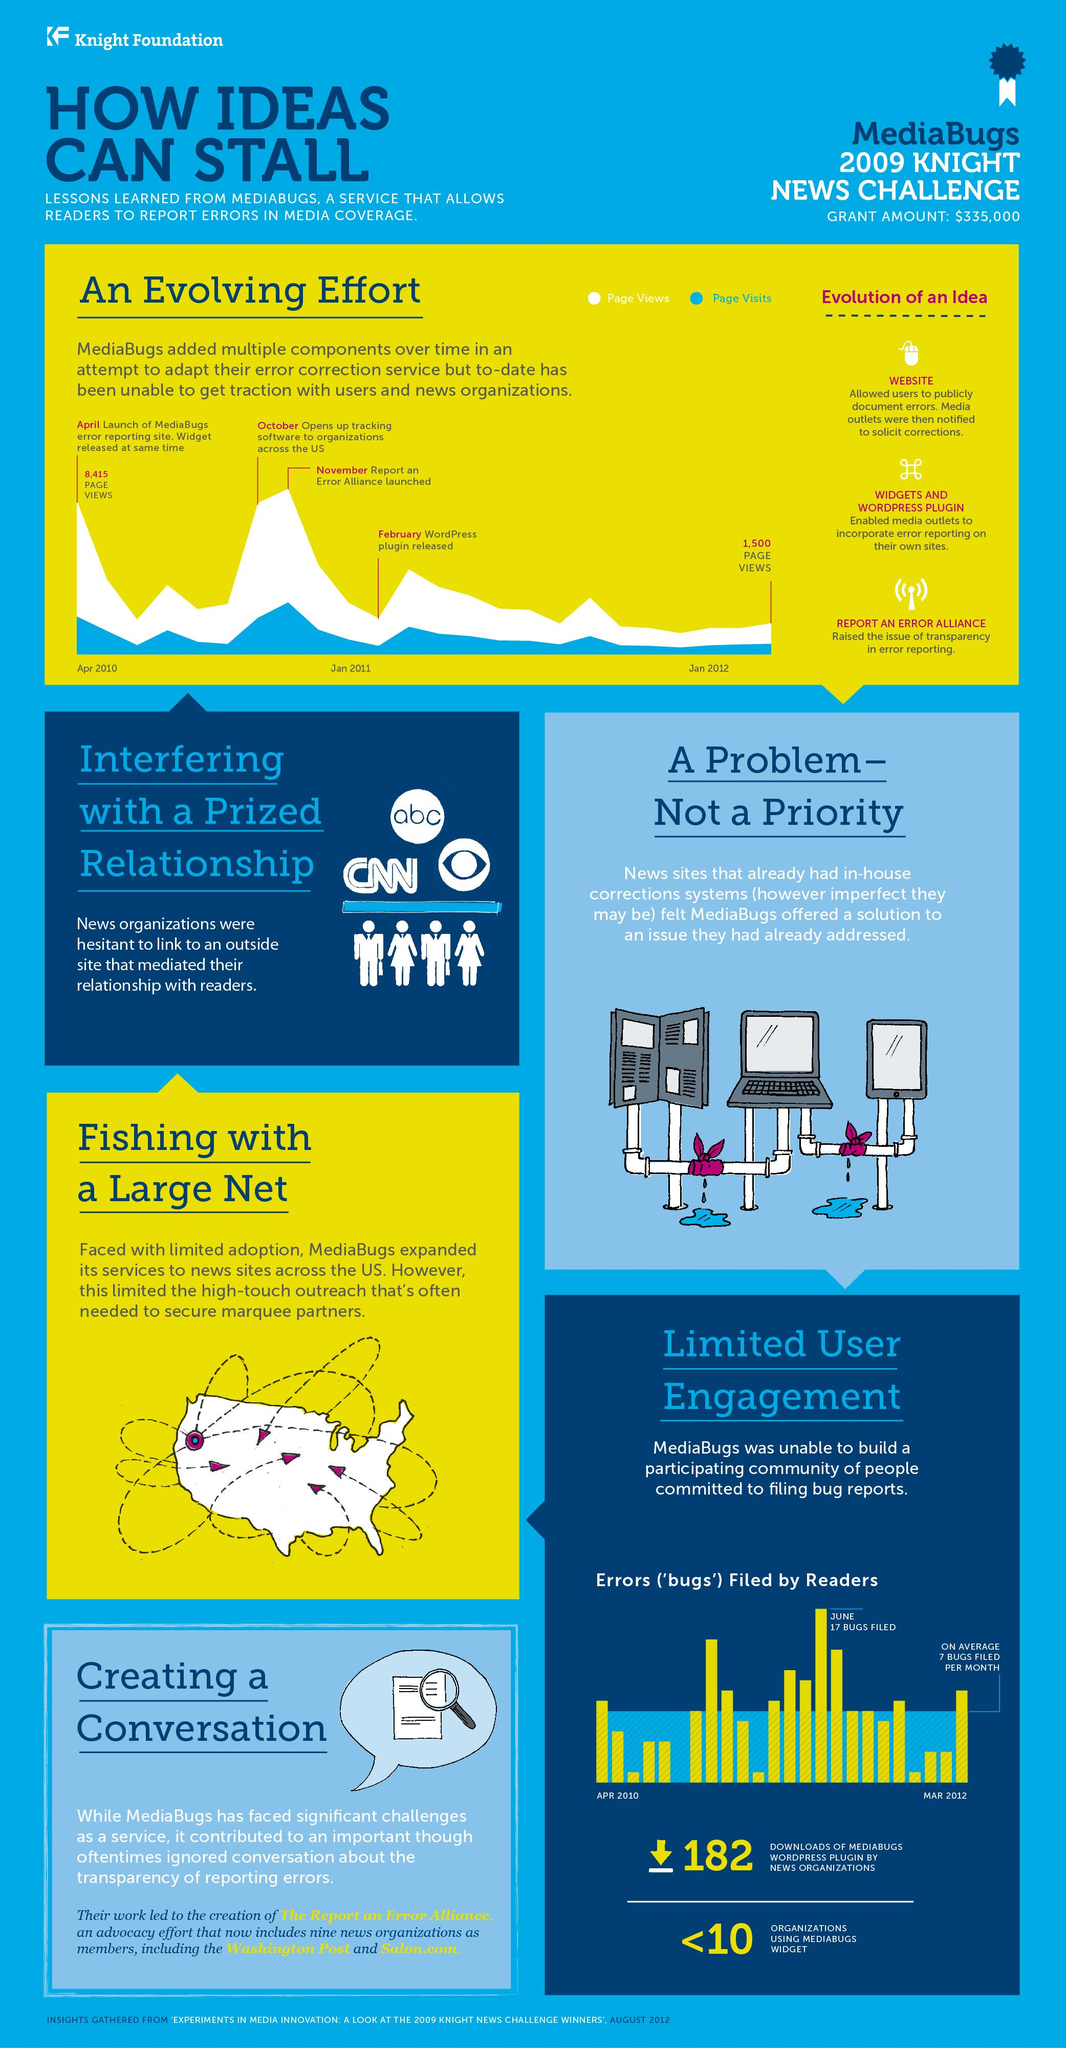Outline some significant characteristics in this image. From April 2010 to April 2012, there was a decrease in page views of 6,915. The news organization with a logo featuring an eye is CBS. The WordPress plugin was released in 2011. The month of September 2010 did not have any reports of bugs filed. The maximum number of media bugs filed was in 2011. 